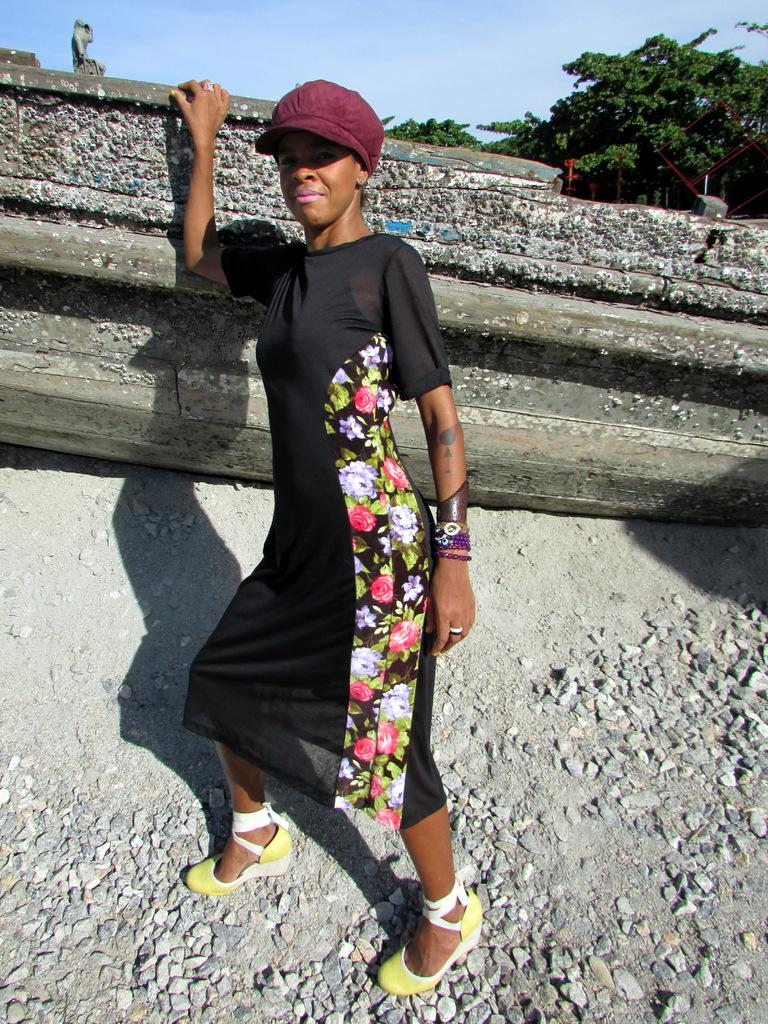What is the woman doing in the image? The woman is standing on the ground in the image. What can be seen on the ground around the woman? There are stones on the ground. What is the woman doing with her hand in the image? The woman has placed her hand on an object. What can be seen in the background of the image? There are trees and objects in the background of the image, as well as the sky. What type of instrument is the woman playing in the image? There is no instrument present in the image, and the woman is not playing any instrument. 